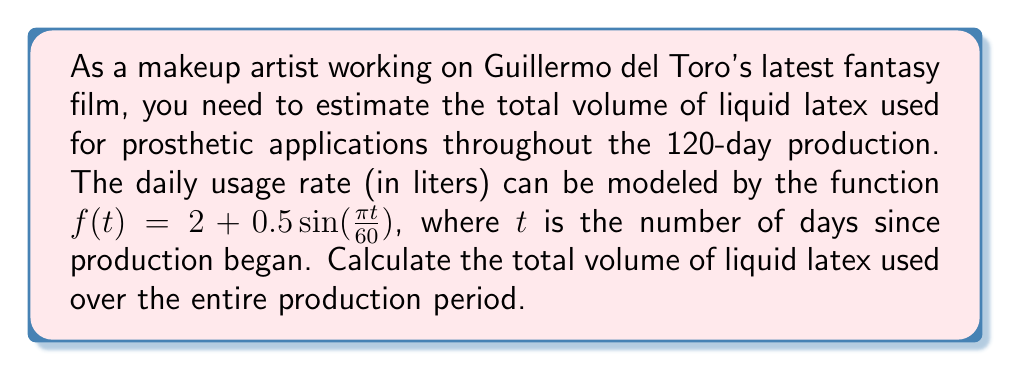Teach me how to tackle this problem. To solve this problem, we need to integrate the given function over the production period:

1) The function describing daily usage is:
   $f(t) = 2 + 0.5\sin(\frac{\pi t}{60})$

2) We need to integrate this function from $t=0$ to $t=120$:
   $$\int_0^{120} (2 + 0.5\sin(\frac{\pi t}{60})) dt$$

3) Let's break this integral into two parts:
   $$\int_0^{120} 2 dt + \int_0^{120} 0.5\sin(\frac{\pi t}{60}) dt$$

4) The first part is straightforward:
   $$\int_0^{120} 2 dt = 2t \bigg|_0^{120} = 240$$

5) For the second part, we use substitution:
   Let $u = \frac{\pi t}{60}$, then $du = \frac{\pi}{60} dt$, or $dt = \frac{60}{\pi} du$
   When $t=0$, $u=0$; when $t=120$, $u=2\pi$

   So the integral becomes:
   $$0.5 \cdot \frac{60}{\pi} \int_0^{2\pi} \sin(u) du$$

6) We know that $\int \sin(u) du = -\cos(u) + C$, so:
   $$0.5 \cdot \frac{60}{\pi} [-\cos(u)]_0^{2\pi} = \frac{30}{\pi} [-\cos(2\pi) + \cos(0)] = 0$$

7) Adding the results from steps 4 and 6:
   Total volume = 240 + 0 = 240 liters
Answer: 240 liters 